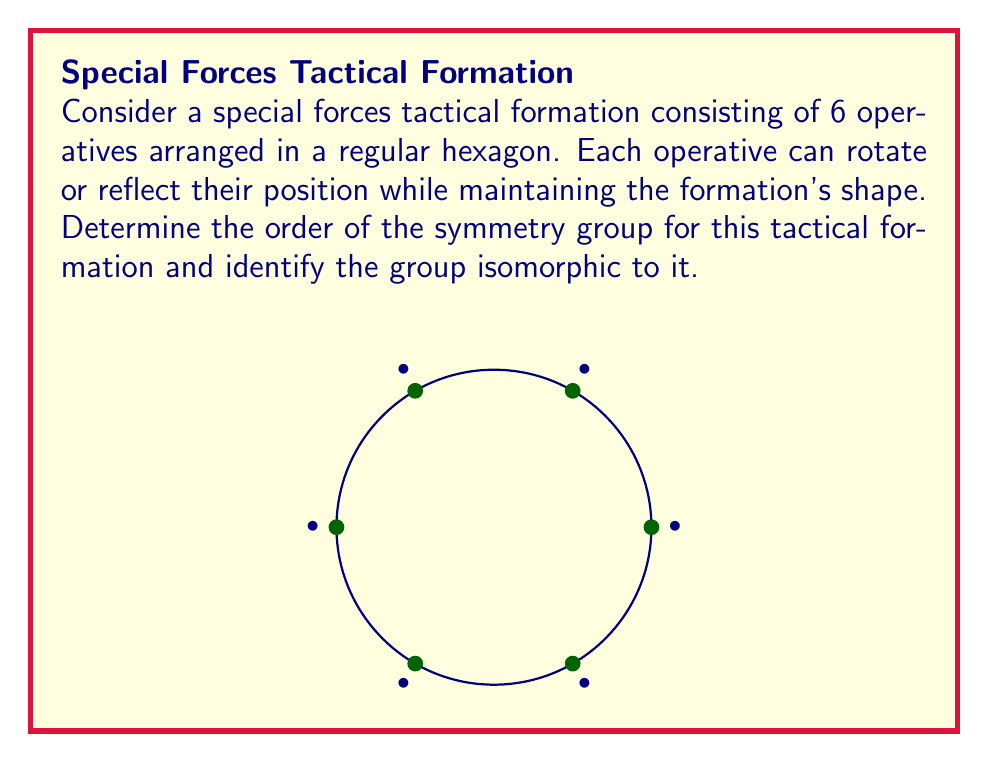Solve this math problem. Let's approach this step-by-step:

1) The symmetries of a regular hexagon form the dihedral group $D_6$. This group includes rotations and reflections that preserve the shape of the hexagon.

2) To find the order of the group, we need to count the number of symmetries:

   a) Rotations: There are 6 rotational symmetries (including the identity rotation):
      $$0°, 60°, 120°, 180°, 240°, 300°$$

   b) Reflections: There are 6 reflection symmetries:
      - 3 reflections across lines through opposite vertices
      - 3 reflections across lines through the midpoints of opposite sides

3) The total number of symmetries is thus $6 + 6 = 12$. This is the order of the symmetry group.

4) The dihedral group $D_6$ has the following properties:
   - It has order 12
   - It is non-abelian
   - It has 6 elements of order 2 (reflections)
   - It has 2 elements of order 3, 2 elements of order 6, and 1 element of order 1 (identity)

5) The group $D_6$ is isomorphic to the direct product $S_3 \times \mathbb{Z}_2$, where $S_3$ is the symmetric group on 3 elements and $\mathbb{Z}_2$ is the cyclic group of order 2.
Answer: Order: 12; Isomorphic to $D_6 \cong S_3 \times \mathbb{Z}_2$ 